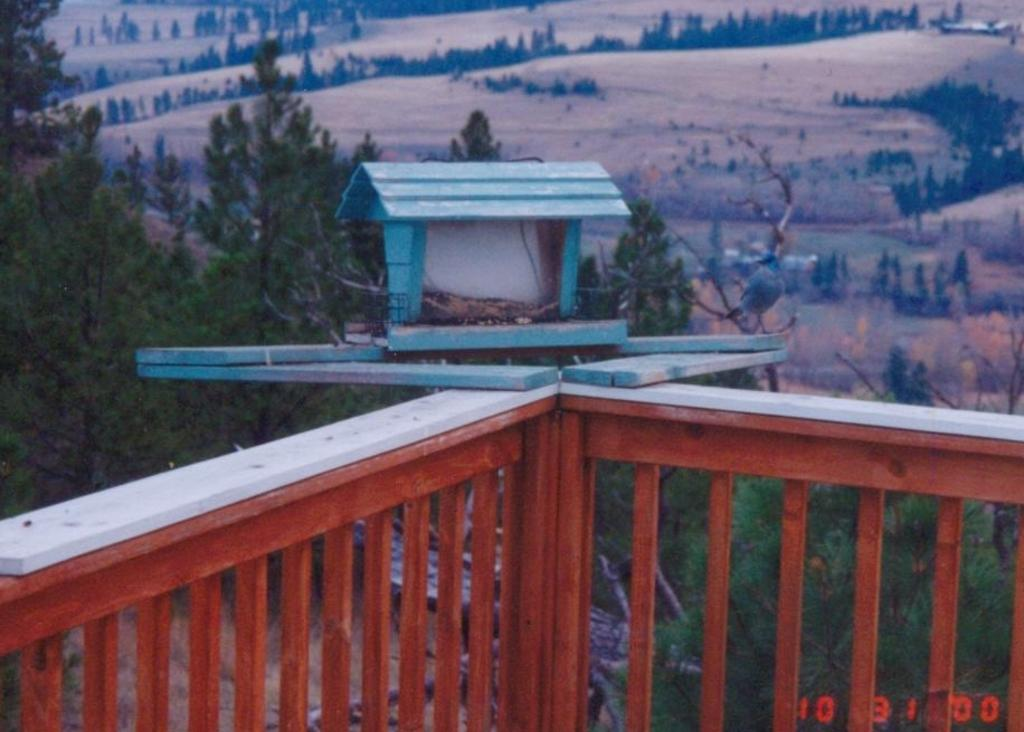What is the main subject of the image? There is a doll house in the image. Where is the doll house located? The doll house is placed on a wooden railing. What can be seen in the background of the image? There is a group of trees in the background of the image. How much gold can be seen in the image? There is no gold present in the image. Can you hear anyone coughing in the image? There is no sound or indication of anyone coughing in the image. 